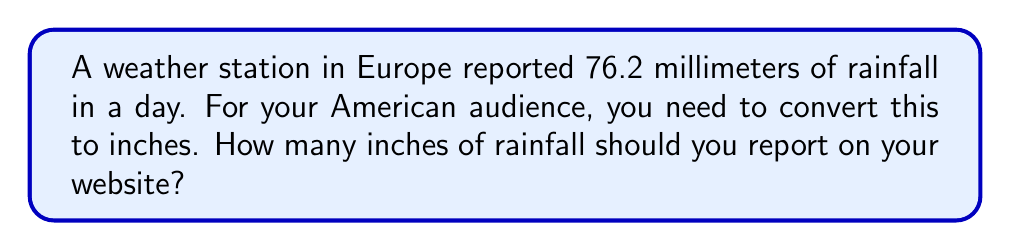Give your solution to this math problem. To convert millimeters to inches, we need to use the conversion factor:
1 inch = 25.4 millimeters

Let's set up the conversion:
$$ \frac{76.2 \text{ mm}}{x \text{ inches}} = \frac{25.4 \text{ mm}}{1 \text{ inch}} $$

Cross multiply:
$$ 76.2 \cdot 1 = 25.4x $$

Solve for $x$:
$$ x = \frac{76.2}{25.4} $$

Using a calculator:
$$ x \approx 3 \text{ inches} $$

To be more precise:
$$ x \approx 3.0000 \text{ inches} $$

Rounding to two decimal places, which is common for rainfall measurements:
$$ x \approx 3.00 \text{ inches} $$
Answer: 3.00 inches 